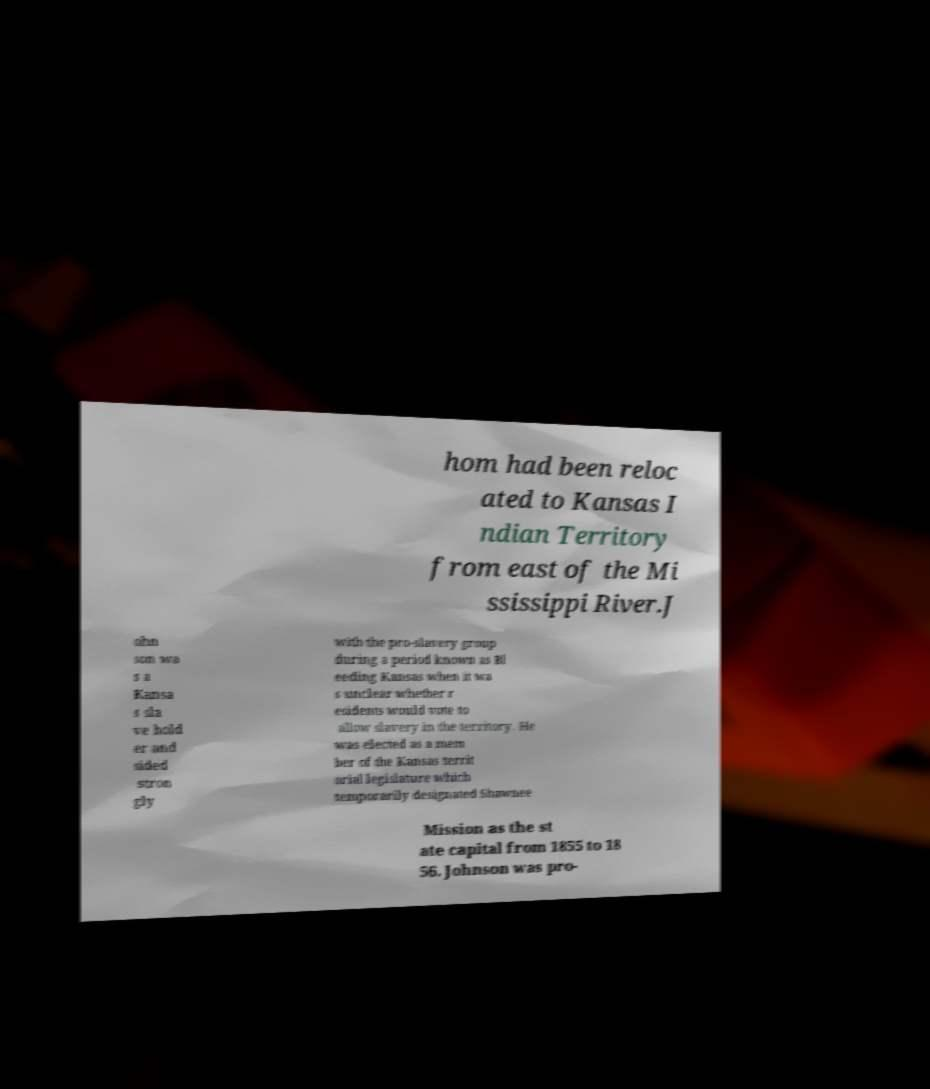I need the written content from this picture converted into text. Can you do that? hom had been reloc ated to Kansas I ndian Territory from east of the Mi ssissippi River.J ohn son wa s a Kansa s sla ve hold er and sided stron gly with the pro-slavery group during a period known as Bl eeding Kansas when it wa s unclear whether r esidents would vote to allow slavery in the territory. He was elected as a mem ber of the Kansas territ orial legislature which temporarily designated Shawnee Mission as the st ate capital from 1855 to 18 56. Johnson was pro- 